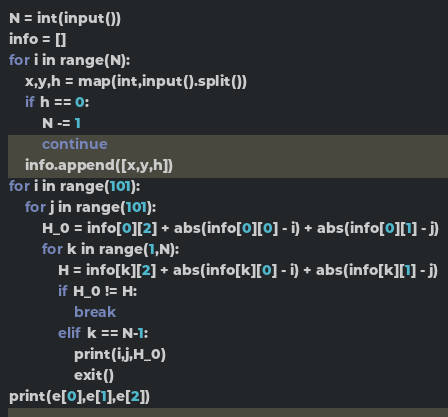<code> <loc_0><loc_0><loc_500><loc_500><_Python_>N = int(input())
info = []
for i in range(N):
    x,y,h = map(int,input().split())
    if h == 0:
        N -= 1
        continue
    info.append([x,y,h])
for i in range(101):
    for j in range(101):
        H_0 = info[0][2] + abs(info[0][0] - i) + abs(info[0][1] - j)
        for k in range(1,N):
            H = info[k][2] + abs(info[k][0] - i) + abs(info[k][1] - j)
            if H_0 != H:
                break
            elif k == N-1:
                print(i,j,H_0)
                exit()
print(e[0],e[1],e[2])</code> 